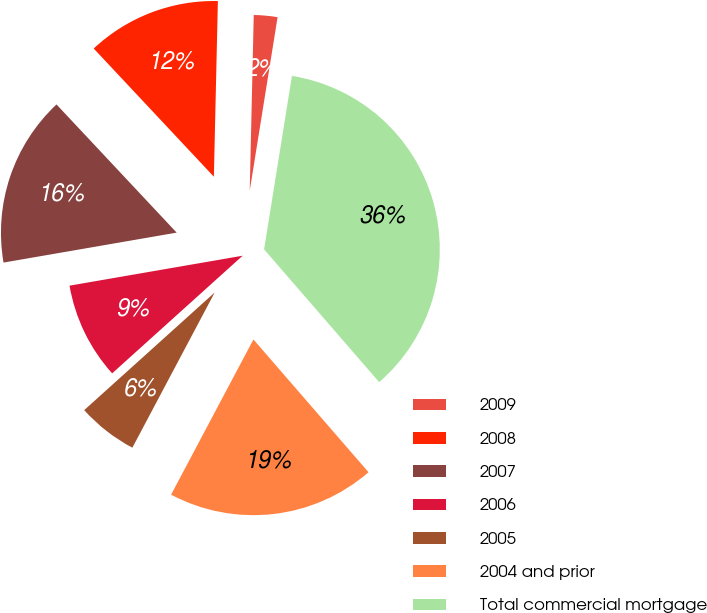<chart> <loc_0><loc_0><loc_500><loc_500><pie_chart><fcel>2009<fcel>2008<fcel>2007<fcel>2006<fcel>2005<fcel>2004 and prior<fcel>Total commercial mortgage<nl><fcel>2.17%<fcel>12.35%<fcel>15.74%<fcel>8.95%<fcel>5.56%<fcel>19.13%<fcel>36.1%<nl></chart> 